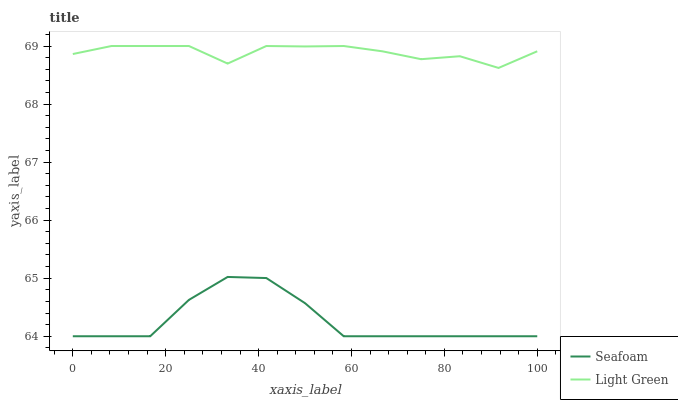Does Seafoam have the minimum area under the curve?
Answer yes or no. Yes. Does Light Green have the maximum area under the curve?
Answer yes or no. Yes. Does Light Green have the minimum area under the curve?
Answer yes or no. No. Is Seafoam the smoothest?
Answer yes or no. Yes. Is Light Green the roughest?
Answer yes or no. Yes. Is Light Green the smoothest?
Answer yes or no. No. Does Seafoam have the lowest value?
Answer yes or no. Yes. Does Light Green have the lowest value?
Answer yes or no. No. Does Light Green have the highest value?
Answer yes or no. Yes. Is Seafoam less than Light Green?
Answer yes or no. Yes. Is Light Green greater than Seafoam?
Answer yes or no. Yes. Does Seafoam intersect Light Green?
Answer yes or no. No. 